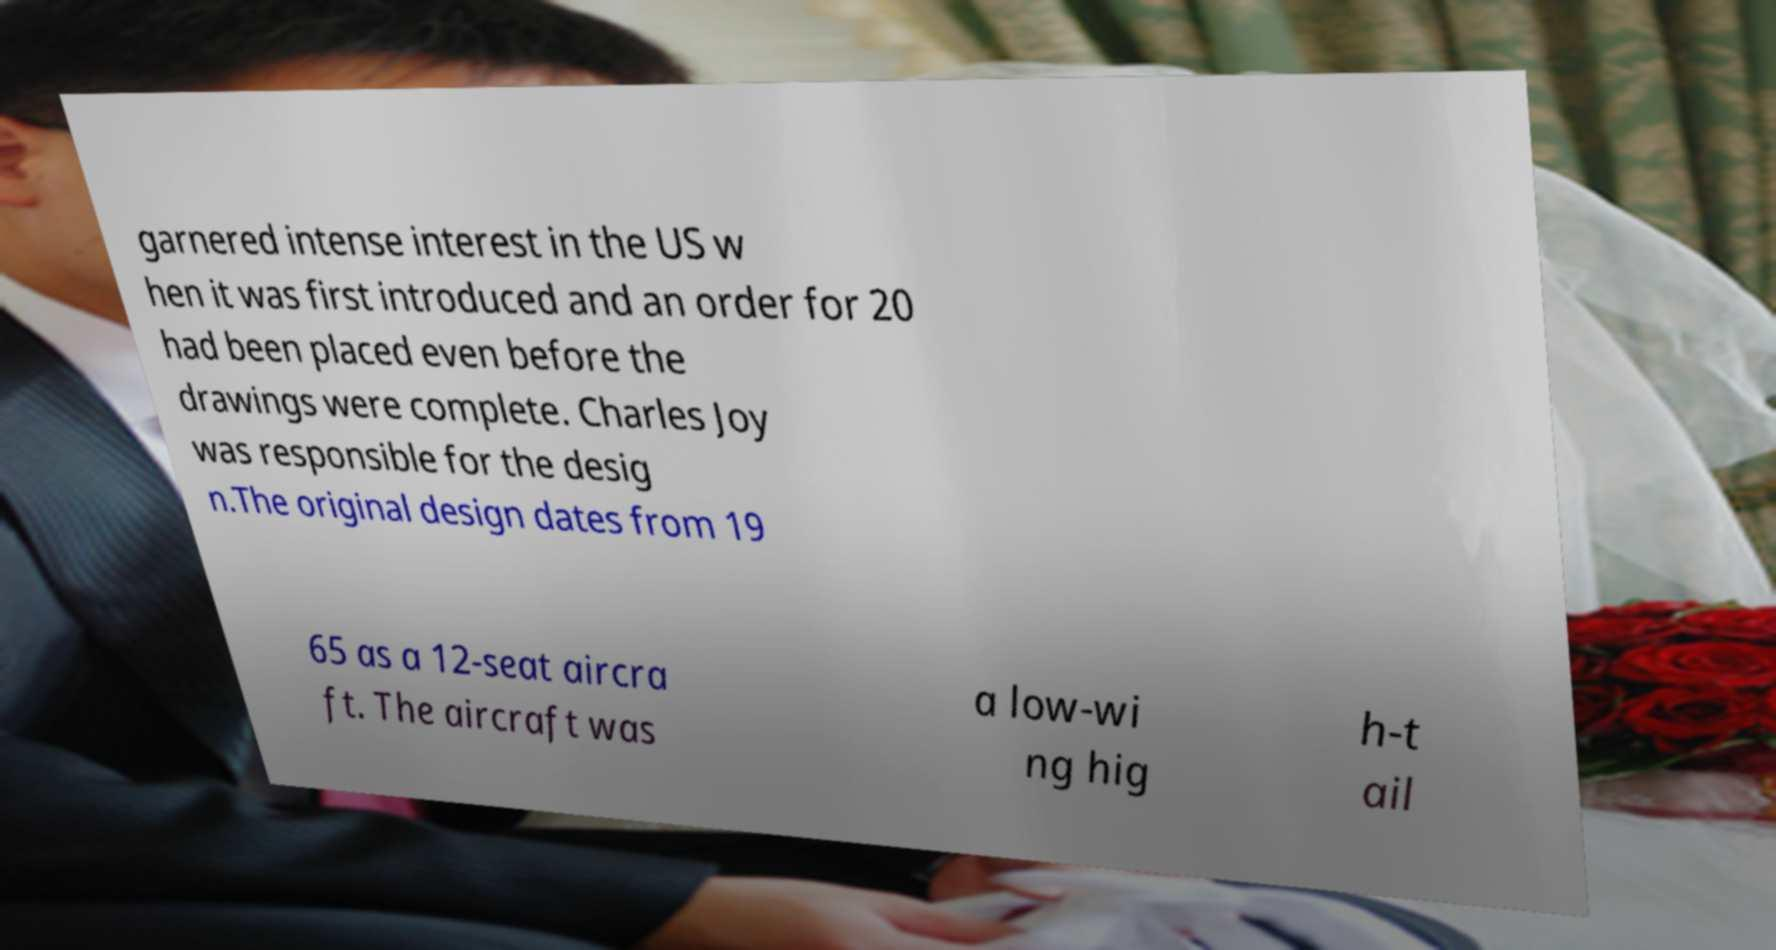Can you accurately transcribe the text from the provided image for me? garnered intense interest in the US w hen it was first introduced and an order for 20 had been placed even before the drawings were complete. Charles Joy was responsible for the desig n.The original design dates from 19 65 as a 12-seat aircra ft. The aircraft was a low-wi ng hig h-t ail 